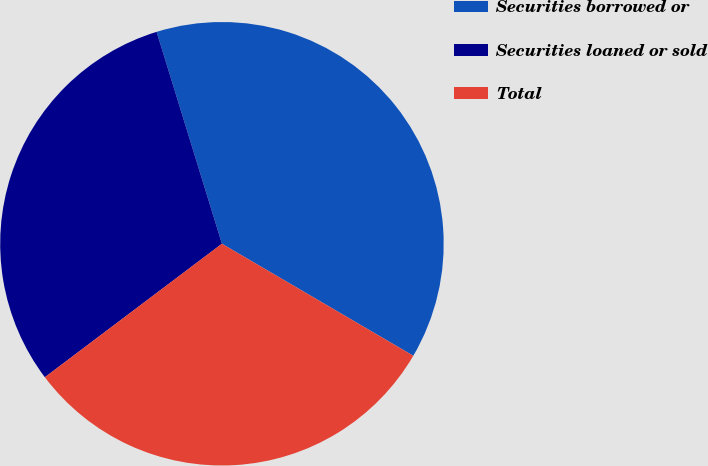Convert chart. <chart><loc_0><loc_0><loc_500><loc_500><pie_chart><fcel>Securities borrowed or<fcel>Securities loaned or sold<fcel>Total<nl><fcel>38.19%<fcel>30.52%<fcel>31.29%<nl></chart> 